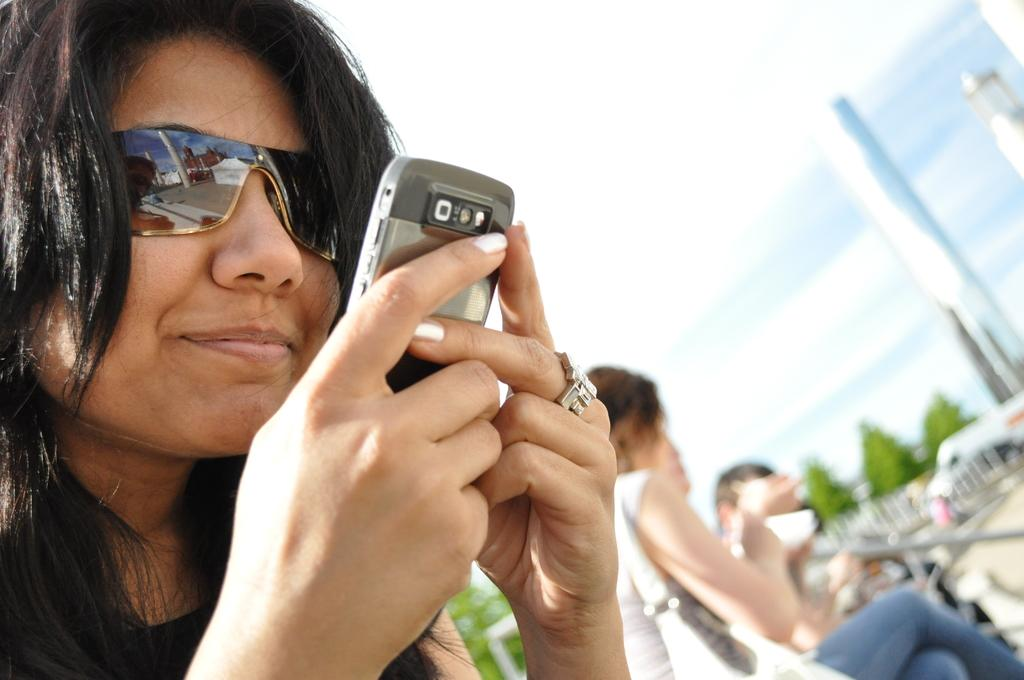What is the person in the image holding? The person is holding a mobile. What is the position of the person in the image? The person is sitting. What type of structure can be seen in the image? There is a building in the image. What part of the natural environment is visible in the image? The sky and trees are visible in the image. What mode of transportation can be seen in the image? There is a vehicle in the image. What type of coal is being mined in the image? There is no coal or mining activity present in the image. What discovery was made by the person in the image? There is no indication of a discovery being made in the image. 